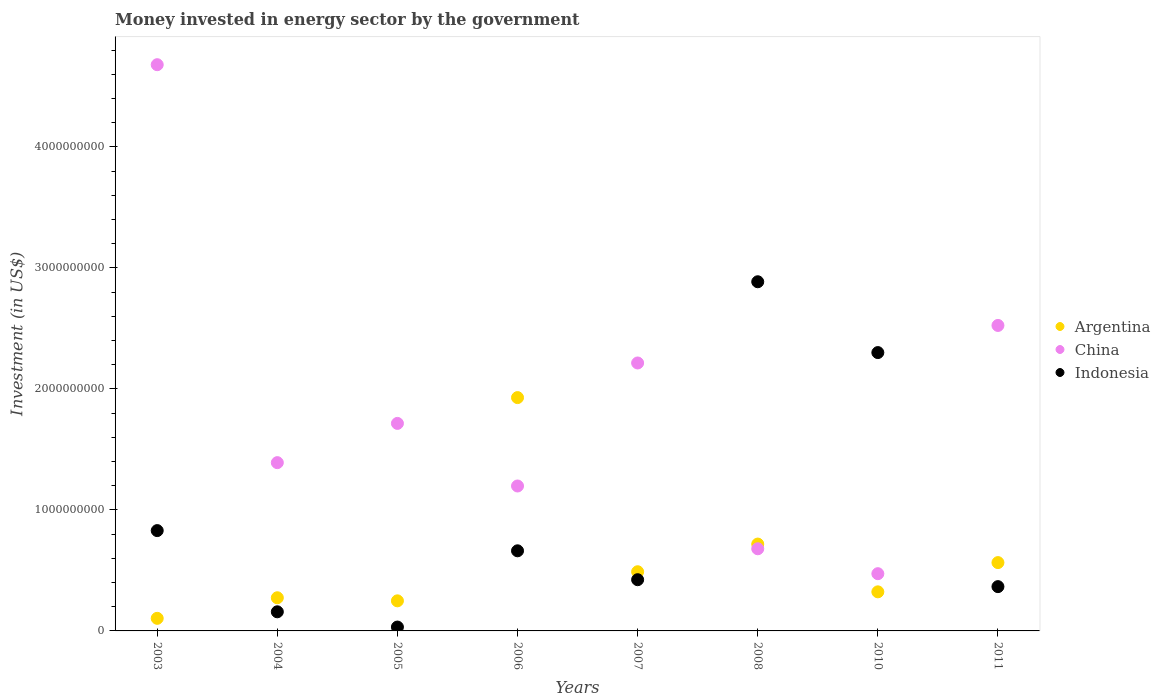How many different coloured dotlines are there?
Offer a very short reply. 3. What is the money spent in energy sector in Indonesia in 2005?
Make the answer very short. 3.20e+07. Across all years, what is the maximum money spent in energy sector in Argentina?
Keep it short and to the point. 1.93e+09. Across all years, what is the minimum money spent in energy sector in Indonesia?
Ensure brevity in your answer.  3.20e+07. In which year was the money spent in energy sector in Indonesia minimum?
Make the answer very short. 2005. What is the total money spent in energy sector in China in the graph?
Your answer should be compact. 1.49e+1. What is the difference between the money spent in energy sector in China in 2007 and that in 2011?
Make the answer very short. -3.10e+08. What is the difference between the money spent in energy sector in China in 2008 and the money spent in energy sector in Argentina in 2007?
Offer a terse response. 1.90e+08. What is the average money spent in energy sector in Indonesia per year?
Provide a succinct answer. 9.57e+08. In the year 2003, what is the difference between the money spent in energy sector in China and money spent in energy sector in Indonesia?
Your answer should be very brief. 3.85e+09. What is the ratio of the money spent in energy sector in Argentina in 2003 to that in 2008?
Offer a terse response. 0.14. Is the money spent in energy sector in China in 2003 less than that in 2004?
Offer a very short reply. No. What is the difference between the highest and the second highest money spent in energy sector in Argentina?
Your answer should be compact. 1.21e+09. What is the difference between the highest and the lowest money spent in energy sector in China?
Keep it short and to the point. 4.21e+09. In how many years, is the money spent in energy sector in Argentina greater than the average money spent in energy sector in Argentina taken over all years?
Give a very brief answer. 2. Is the sum of the money spent in energy sector in Indonesia in 2005 and 2007 greater than the maximum money spent in energy sector in China across all years?
Offer a terse response. No. Is the money spent in energy sector in Argentina strictly less than the money spent in energy sector in Indonesia over the years?
Offer a terse response. No. How many years are there in the graph?
Offer a terse response. 8. What is the difference between two consecutive major ticks on the Y-axis?
Give a very brief answer. 1.00e+09. Does the graph contain any zero values?
Give a very brief answer. No. How are the legend labels stacked?
Offer a terse response. Vertical. What is the title of the graph?
Offer a very short reply. Money invested in energy sector by the government. Does "Iran" appear as one of the legend labels in the graph?
Your answer should be very brief. No. What is the label or title of the Y-axis?
Provide a short and direct response. Investment (in US$). What is the Investment (in US$) of Argentina in 2003?
Provide a short and direct response. 1.04e+08. What is the Investment (in US$) in China in 2003?
Offer a very short reply. 4.68e+09. What is the Investment (in US$) in Indonesia in 2003?
Give a very brief answer. 8.29e+08. What is the Investment (in US$) of Argentina in 2004?
Offer a very short reply. 2.74e+08. What is the Investment (in US$) of China in 2004?
Your response must be concise. 1.39e+09. What is the Investment (in US$) in Indonesia in 2004?
Provide a short and direct response. 1.58e+08. What is the Investment (in US$) of Argentina in 2005?
Give a very brief answer. 2.49e+08. What is the Investment (in US$) in China in 2005?
Offer a very short reply. 1.71e+09. What is the Investment (in US$) of Indonesia in 2005?
Your answer should be compact. 3.20e+07. What is the Investment (in US$) in Argentina in 2006?
Your answer should be compact. 1.93e+09. What is the Investment (in US$) in China in 2006?
Give a very brief answer. 1.20e+09. What is the Investment (in US$) of Indonesia in 2006?
Make the answer very short. 6.62e+08. What is the Investment (in US$) in Argentina in 2007?
Keep it short and to the point. 4.89e+08. What is the Investment (in US$) in China in 2007?
Provide a succinct answer. 2.21e+09. What is the Investment (in US$) of Indonesia in 2007?
Offer a terse response. 4.23e+08. What is the Investment (in US$) of Argentina in 2008?
Provide a succinct answer. 7.18e+08. What is the Investment (in US$) of China in 2008?
Provide a succinct answer. 6.79e+08. What is the Investment (in US$) of Indonesia in 2008?
Ensure brevity in your answer.  2.89e+09. What is the Investment (in US$) in Argentina in 2010?
Provide a short and direct response. 3.23e+08. What is the Investment (in US$) in China in 2010?
Offer a very short reply. 4.73e+08. What is the Investment (in US$) in Indonesia in 2010?
Ensure brevity in your answer.  2.30e+09. What is the Investment (in US$) in Argentina in 2011?
Offer a terse response. 5.65e+08. What is the Investment (in US$) of China in 2011?
Your answer should be very brief. 2.52e+09. What is the Investment (in US$) in Indonesia in 2011?
Provide a short and direct response. 3.66e+08. Across all years, what is the maximum Investment (in US$) in Argentina?
Give a very brief answer. 1.93e+09. Across all years, what is the maximum Investment (in US$) of China?
Your response must be concise. 4.68e+09. Across all years, what is the maximum Investment (in US$) of Indonesia?
Your answer should be compact. 2.89e+09. Across all years, what is the minimum Investment (in US$) of Argentina?
Offer a terse response. 1.04e+08. Across all years, what is the minimum Investment (in US$) of China?
Provide a short and direct response. 4.73e+08. Across all years, what is the minimum Investment (in US$) of Indonesia?
Your answer should be compact. 3.20e+07. What is the total Investment (in US$) in Argentina in the graph?
Your answer should be compact. 4.65e+09. What is the total Investment (in US$) of China in the graph?
Provide a short and direct response. 1.49e+1. What is the total Investment (in US$) of Indonesia in the graph?
Keep it short and to the point. 7.66e+09. What is the difference between the Investment (in US$) of Argentina in 2003 and that in 2004?
Ensure brevity in your answer.  -1.70e+08. What is the difference between the Investment (in US$) of China in 2003 and that in 2004?
Give a very brief answer. 3.29e+09. What is the difference between the Investment (in US$) of Indonesia in 2003 and that in 2004?
Keep it short and to the point. 6.71e+08. What is the difference between the Investment (in US$) in Argentina in 2003 and that in 2005?
Provide a short and direct response. -1.45e+08. What is the difference between the Investment (in US$) in China in 2003 and that in 2005?
Provide a succinct answer. 2.96e+09. What is the difference between the Investment (in US$) of Indonesia in 2003 and that in 2005?
Ensure brevity in your answer.  7.97e+08. What is the difference between the Investment (in US$) in Argentina in 2003 and that in 2006?
Provide a short and direct response. -1.82e+09. What is the difference between the Investment (in US$) in China in 2003 and that in 2006?
Your answer should be very brief. 3.48e+09. What is the difference between the Investment (in US$) in Indonesia in 2003 and that in 2006?
Keep it short and to the point. 1.67e+08. What is the difference between the Investment (in US$) in Argentina in 2003 and that in 2007?
Make the answer very short. -3.85e+08. What is the difference between the Investment (in US$) of China in 2003 and that in 2007?
Provide a short and direct response. 2.46e+09. What is the difference between the Investment (in US$) in Indonesia in 2003 and that in 2007?
Offer a very short reply. 4.06e+08. What is the difference between the Investment (in US$) in Argentina in 2003 and that in 2008?
Provide a succinct answer. -6.14e+08. What is the difference between the Investment (in US$) in China in 2003 and that in 2008?
Offer a very short reply. 4.00e+09. What is the difference between the Investment (in US$) in Indonesia in 2003 and that in 2008?
Ensure brevity in your answer.  -2.06e+09. What is the difference between the Investment (in US$) of Argentina in 2003 and that in 2010?
Make the answer very short. -2.19e+08. What is the difference between the Investment (in US$) in China in 2003 and that in 2010?
Ensure brevity in your answer.  4.21e+09. What is the difference between the Investment (in US$) in Indonesia in 2003 and that in 2010?
Your answer should be compact. -1.47e+09. What is the difference between the Investment (in US$) in Argentina in 2003 and that in 2011?
Offer a terse response. -4.61e+08. What is the difference between the Investment (in US$) in China in 2003 and that in 2011?
Your answer should be very brief. 2.15e+09. What is the difference between the Investment (in US$) in Indonesia in 2003 and that in 2011?
Provide a succinct answer. 4.63e+08. What is the difference between the Investment (in US$) of Argentina in 2004 and that in 2005?
Make the answer very short. 2.54e+07. What is the difference between the Investment (in US$) in China in 2004 and that in 2005?
Your response must be concise. -3.24e+08. What is the difference between the Investment (in US$) of Indonesia in 2004 and that in 2005?
Ensure brevity in your answer.  1.26e+08. What is the difference between the Investment (in US$) of Argentina in 2004 and that in 2006?
Offer a terse response. -1.65e+09. What is the difference between the Investment (in US$) of China in 2004 and that in 2006?
Offer a terse response. 1.93e+08. What is the difference between the Investment (in US$) in Indonesia in 2004 and that in 2006?
Keep it short and to the point. -5.04e+08. What is the difference between the Investment (in US$) of Argentina in 2004 and that in 2007?
Offer a terse response. -2.15e+08. What is the difference between the Investment (in US$) in China in 2004 and that in 2007?
Offer a very short reply. -8.24e+08. What is the difference between the Investment (in US$) in Indonesia in 2004 and that in 2007?
Ensure brevity in your answer.  -2.65e+08. What is the difference between the Investment (in US$) in Argentina in 2004 and that in 2008?
Provide a short and direct response. -4.44e+08. What is the difference between the Investment (in US$) of China in 2004 and that in 2008?
Offer a very short reply. 7.12e+08. What is the difference between the Investment (in US$) of Indonesia in 2004 and that in 2008?
Your answer should be compact. -2.73e+09. What is the difference between the Investment (in US$) of Argentina in 2004 and that in 2010?
Provide a short and direct response. -4.89e+07. What is the difference between the Investment (in US$) of China in 2004 and that in 2010?
Your answer should be very brief. 9.18e+08. What is the difference between the Investment (in US$) in Indonesia in 2004 and that in 2010?
Ensure brevity in your answer.  -2.14e+09. What is the difference between the Investment (in US$) in Argentina in 2004 and that in 2011?
Ensure brevity in your answer.  -2.91e+08. What is the difference between the Investment (in US$) in China in 2004 and that in 2011?
Offer a terse response. -1.13e+09. What is the difference between the Investment (in US$) of Indonesia in 2004 and that in 2011?
Keep it short and to the point. -2.08e+08. What is the difference between the Investment (in US$) in Argentina in 2005 and that in 2006?
Offer a terse response. -1.68e+09. What is the difference between the Investment (in US$) in China in 2005 and that in 2006?
Your answer should be very brief. 5.17e+08. What is the difference between the Investment (in US$) of Indonesia in 2005 and that in 2006?
Your answer should be very brief. -6.30e+08. What is the difference between the Investment (in US$) in Argentina in 2005 and that in 2007?
Make the answer very short. -2.40e+08. What is the difference between the Investment (in US$) of China in 2005 and that in 2007?
Your answer should be very brief. -4.99e+08. What is the difference between the Investment (in US$) of Indonesia in 2005 and that in 2007?
Your answer should be compact. -3.91e+08. What is the difference between the Investment (in US$) of Argentina in 2005 and that in 2008?
Make the answer very short. -4.69e+08. What is the difference between the Investment (in US$) of China in 2005 and that in 2008?
Make the answer very short. 1.04e+09. What is the difference between the Investment (in US$) of Indonesia in 2005 and that in 2008?
Ensure brevity in your answer.  -2.85e+09. What is the difference between the Investment (in US$) of Argentina in 2005 and that in 2010?
Give a very brief answer. -7.43e+07. What is the difference between the Investment (in US$) of China in 2005 and that in 2010?
Make the answer very short. 1.24e+09. What is the difference between the Investment (in US$) of Indonesia in 2005 and that in 2010?
Give a very brief answer. -2.27e+09. What is the difference between the Investment (in US$) in Argentina in 2005 and that in 2011?
Provide a short and direct response. -3.16e+08. What is the difference between the Investment (in US$) of China in 2005 and that in 2011?
Give a very brief answer. -8.09e+08. What is the difference between the Investment (in US$) in Indonesia in 2005 and that in 2011?
Give a very brief answer. -3.34e+08. What is the difference between the Investment (in US$) in Argentina in 2006 and that in 2007?
Make the answer very short. 1.44e+09. What is the difference between the Investment (in US$) of China in 2006 and that in 2007?
Provide a succinct answer. -1.02e+09. What is the difference between the Investment (in US$) in Indonesia in 2006 and that in 2007?
Keep it short and to the point. 2.39e+08. What is the difference between the Investment (in US$) in Argentina in 2006 and that in 2008?
Provide a short and direct response. 1.21e+09. What is the difference between the Investment (in US$) of China in 2006 and that in 2008?
Keep it short and to the point. 5.19e+08. What is the difference between the Investment (in US$) of Indonesia in 2006 and that in 2008?
Offer a very short reply. -2.22e+09. What is the difference between the Investment (in US$) in Argentina in 2006 and that in 2010?
Ensure brevity in your answer.  1.61e+09. What is the difference between the Investment (in US$) of China in 2006 and that in 2010?
Keep it short and to the point. 7.25e+08. What is the difference between the Investment (in US$) of Indonesia in 2006 and that in 2010?
Offer a terse response. -1.64e+09. What is the difference between the Investment (in US$) of Argentina in 2006 and that in 2011?
Ensure brevity in your answer.  1.36e+09. What is the difference between the Investment (in US$) in China in 2006 and that in 2011?
Offer a terse response. -1.33e+09. What is the difference between the Investment (in US$) of Indonesia in 2006 and that in 2011?
Make the answer very short. 2.96e+08. What is the difference between the Investment (in US$) in Argentina in 2007 and that in 2008?
Your answer should be very brief. -2.29e+08. What is the difference between the Investment (in US$) in China in 2007 and that in 2008?
Offer a very short reply. 1.54e+09. What is the difference between the Investment (in US$) in Indonesia in 2007 and that in 2008?
Keep it short and to the point. -2.46e+09. What is the difference between the Investment (in US$) in Argentina in 2007 and that in 2010?
Offer a very short reply. 1.66e+08. What is the difference between the Investment (in US$) of China in 2007 and that in 2010?
Ensure brevity in your answer.  1.74e+09. What is the difference between the Investment (in US$) of Indonesia in 2007 and that in 2010?
Give a very brief answer. -1.88e+09. What is the difference between the Investment (in US$) of Argentina in 2007 and that in 2011?
Offer a very short reply. -7.56e+07. What is the difference between the Investment (in US$) of China in 2007 and that in 2011?
Your response must be concise. -3.10e+08. What is the difference between the Investment (in US$) of Indonesia in 2007 and that in 2011?
Your response must be concise. 5.72e+07. What is the difference between the Investment (in US$) of Argentina in 2008 and that in 2010?
Your answer should be very brief. 3.95e+08. What is the difference between the Investment (in US$) in China in 2008 and that in 2010?
Your answer should be compact. 2.06e+08. What is the difference between the Investment (in US$) of Indonesia in 2008 and that in 2010?
Offer a terse response. 5.85e+08. What is the difference between the Investment (in US$) of Argentina in 2008 and that in 2011?
Give a very brief answer. 1.53e+08. What is the difference between the Investment (in US$) of China in 2008 and that in 2011?
Offer a terse response. -1.85e+09. What is the difference between the Investment (in US$) of Indonesia in 2008 and that in 2011?
Your response must be concise. 2.52e+09. What is the difference between the Investment (in US$) in Argentina in 2010 and that in 2011?
Offer a terse response. -2.42e+08. What is the difference between the Investment (in US$) of China in 2010 and that in 2011?
Offer a very short reply. -2.05e+09. What is the difference between the Investment (in US$) of Indonesia in 2010 and that in 2011?
Make the answer very short. 1.93e+09. What is the difference between the Investment (in US$) of Argentina in 2003 and the Investment (in US$) of China in 2004?
Provide a succinct answer. -1.29e+09. What is the difference between the Investment (in US$) of Argentina in 2003 and the Investment (in US$) of Indonesia in 2004?
Offer a very short reply. -5.40e+07. What is the difference between the Investment (in US$) in China in 2003 and the Investment (in US$) in Indonesia in 2004?
Make the answer very short. 4.52e+09. What is the difference between the Investment (in US$) in Argentina in 2003 and the Investment (in US$) in China in 2005?
Give a very brief answer. -1.61e+09. What is the difference between the Investment (in US$) in Argentina in 2003 and the Investment (in US$) in Indonesia in 2005?
Give a very brief answer. 7.20e+07. What is the difference between the Investment (in US$) of China in 2003 and the Investment (in US$) of Indonesia in 2005?
Ensure brevity in your answer.  4.65e+09. What is the difference between the Investment (in US$) of Argentina in 2003 and the Investment (in US$) of China in 2006?
Offer a terse response. -1.09e+09. What is the difference between the Investment (in US$) of Argentina in 2003 and the Investment (in US$) of Indonesia in 2006?
Provide a short and direct response. -5.58e+08. What is the difference between the Investment (in US$) in China in 2003 and the Investment (in US$) in Indonesia in 2006?
Offer a very short reply. 4.02e+09. What is the difference between the Investment (in US$) in Argentina in 2003 and the Investment (in US$) in China in 2007?
Give a very brief answer. -2.11e+09. What is the difference between the Investment (in US$) in Argentina in 2003 and the Investment (in US$) in Indonesia in 2007?
Provide a short and direct response. -3.19e+08. What is the difference between the Investment (in US$) of China in 2003 and the Investment (in US$) of Indonesia in 2007?
Ensure brevity in your answer.  4.26e+09. What is the difference between the Investment (in US$) in Argentina in 2003 and the Investment (in US$) in China in 2008?
Make the answer very short. -5.75e+08. What is the difference between the Investment (in US$) in Argentina in 2003 and the Investment (in US$) in Indonesia in 2008?
Offer a terse response. -2.78e+09. What is the difference between the Investment (in US$) in China in 2003 and the Investment (in US$) in Indonesia in 2008?
Offer a terse response. 1.79e+09. What is the difference between the Investment (in US$) in Argentina in 2003 and the Investment (in US$) in China in 2010?
Offer a terse response. -3.69e+08. What is the difference between the Investment (in US$) of Argentina in 2003 and the Investment (in US$) of Indonesia in 2010?
Ensure brevity in your answer.  -2.20e+09. What is the difference between the Investment (in US$) of China in 2003 and the Investment (in US$) of Indonesia in 2010?
Keep it short and to the point. 2.38e+09. What is the difference between the Investment (in US$) in Argentina in 2003 and the Investment (in US$) in China in 2011?
Keep it short and to the point. -2.42e+09. What is the difference between the Investment (in US$) in Argentina in 2003 and the Investment (in US$) in Indonesia in 2011?
Your answer should be compact. -2.62e+08. What is the difference between the Investment (in US$) of China in 2003 and the Investment (in US$) of Indonesia in 2011?
Make the answer very short. 4.31e+09. What is the difference between the Investment (in US$) in Argentina in 2004 and the Investment (in US$) in China in 2005?
Give a very brief answer. -1.44e+09. What is the difference between the Investment (in US$) of Argentina in 2004 and the Investment (in US$) of Indonesia in 2005?
Provide a succinct answer. 2.42e+08. What is the difference between the Investment (in US$) in China in 2004 and the Investment (in US$) in Indonesia in 2005?
Ensure brevity in your answer.  1.36e+09. What is the difference between the Investment (in US$) in Argentina in 2004 and the Investment (in US$) in China in 2006?
Make the answer very short. -9.24e+08. What is the difference between the Investment (in US$) of Argentina in 2004 and the Investment (in US$) of Indonesia in 2006?
Make the answer very short. -3.88e+08. What is the difference between the Investment (in US$) in China in 2004 and the Investment (in US$) in Indonesia in 2006?
Give a very brief answer. 7.28e+08. What is the difference between the Investment (in US$) of Argentina in 2004 and the Investment (in US$) of China in 2007?
Offer a very short reply. -1.94e+09. What is the difference between the Investment (in US$) of Argentina in 2004 and the Investment (in US$) of Indonesia in 2007?
Your answer should be compact. -1.49e+08. What is the difference between the Investment (in US$) of China in 2004 and the Investment (in US$) of Indonesia in 2007?
Offer a terse response. 9.67e+08. What is the difference between the Investment (in US$) of Argentina in 2004 and the Investment (in US$) of China in 2008?
Keep it short and to the point. -4.05e+08. What is the difference between the Investment (in US$) in Argentina in 2004 and the Investment (in US$) in Indonesia in 2008?
Ensure brevity in your answer.  -2.61e+09. What is the difference between the Investment (in US$) in China in 2004 and the Investment (in US$) in Indonesia in 2008?
Give a very brief answer. -1.49e+09. What is the difference between the Investment (in US$) of Argentina in 2004 and the Investment (in US$) of China in 2010?
Keep it short and to the point. -1.99e+08. What is the difference between the Investment (in US$) of Argentina in 2004 and the Investment (in US$) of Indonesia in 2010?
Provide a short and direct response. -2.03e+09. What is the difference between the Investment (in US$) of China in 2004 and the Investment (in US$) of Indonesia in 2010?
Keep it short and to the point. -9.10e+08. What is the difference between the Investment (in US$) in Argentina in 2004 and the Investment (in US$) in China in 2011?
Give a very brief answer. -2.25e+09. What is the difference between the Investment (in US$) of Argentina in 2004 and the Investment (in US$) of Indonesia in 2011?
Your answer should be very brief. -9.20e+07. What is the difference between the Investment (in US$) in China in 2004 and the Investment (in US$) in Indonesia in 2011?
Your answer should be compact. 1.02e+09. What is the difference between the Investment (in US$) in Argentina in 2005 and the Investment (in US$) in China in 2006?
Your answer should be very brief. -9.49e+08. What is the difference between the Investment (in US$) of Argentina in 2005 and the Investment (in US$) of Indonesia in 2006?
Your answer should be very brief. -4.13e+08. What is the difference between the Investment (in US$) in China in 2005 and the Investment (in US$) in Indonesia in 2006?
Keep it short and to the point. 1.05e+09. What is the difference between the Investment (in US$) of Argentina in 2005 and the Investment (in US$) of China in 2007?
Your answer should be very brief. -1.97e+09. What is the difference between the Investment (in US$) of Argentina in 2005 and the Investment (in US$) of Indonesia in 2007?
Give a very brief answer. -1.75e+08. What is the difference between the Investment (in US$) of China in 2005 and the Investment (in US$) of Indonesia in 2007?
Make the answer very short. 1.29e+09. What is the difference between the Investment (in US$) of Argentina in 2005 and the Investment (in US$) of China in 2008?
Offer a terse response. -4.30e+08. What is the difference between the Investment (in US$) in Argentina in 2005 and the Investment (in US$) in Indonesia in 2008?
Offer a very short reply. -2.64e+09. What is the difference between the Investment (in US$) in China in 2005 and the Investment (in US$) in Indonesia in 2008?
Offer a terse response. -1.17e+09. What is the difference between the Investment (in US$) of Argentina in 2005 and the Investment (in US$) of China in 2010?
Your answer should be very brief. -2.24e+08. What is the difference between the Investment (in US$) in Argentina in 2005 and the Investment (in US$) in Indonesia in 2010?
Your answer should be compact. -2.05e+09. What is the difference between the Investment (in US$) in China in 2005 and the Investment (in US$) in Indonesia in 2010?
Offer a terse response. -5.85e+08. What is the difference between the Investment (in US$) in Argentina in 2005 and the Investment (in US$) in China in 2011?
Your answer should be very brief. -2.28e+09. What is the difference between the Investment (in US$) of Argentina in 2005 and the Investment (in US$) of Indonesia in 2011?
Keep it short and to the point. -1.17e+08. What is the difference between the Investment (in US$) of China in 2005 and the Investment (in US$) of Indonesia in 2011?
Ensure brevity in your answer.  1.35e+09. What is the difference between the Investment (in US$) in Argentina in 2006 and the Investment (in US$) in China in 2007?
Give a very brief answer. -2.86e+08. What is the difference between the Investment (in US$) of Argentina in 2006 and the Investment (in US$) of Indonesia in 2007?
Provide a succinct answer. 1.50e+09. What is the difference between the Investment (in US$) of China in 2006 and the Investment (in US$) of Indonesia in 2007?
Offer a very short reply. 7.74e+08. What is the difference between the Investment (in US$) in Argentina in 2006 and the Investment (in US$) in China in 2008?
Your answer should be very brief. 1.25e+09. What is the difference between the Investment (in US$) in Argentina in 2006 and the Investment (in US$) in Indonesia in 2008?
Make the answer very short. -9.57e+08. What is the difference between the Investment (in US$) in China in 2006 and the Investment (in US$) in Indonesia in 2008?
Provide a succinct answer. -1.69e+09. What is the difference between the Investment (in US$) of Argentina in 2006 and the Investment (in US$) of China in 2010?
Ensure brevity in your answer.  1.46e+09. What is the difference between the Investment (in US$) of Argentina in 2006 and the Investment (in US$) of Indonesia in 2010?
Provide a short and direct response. -3.72e+08. What is the difference between the Investment (in US$) of China in 2006 and the Investment (in US$) of Indonesia in 2010?
Your answer should be very brief. -1.10e+09. What is the difference between the Investment (in US$) in Argentina in 2006 and the Investment (in US$) in China in 2011?
Provide a short and direct response. -5.96e+08. What is the difference between the Investment (in US$) of Argentina in 2006 and the Investment (in US$) of Indonesia in 2011?
Provide a short and direct response. 1.56e+09. What is the difference between the Investment (in US$) in China in 2006 and the Investment (in US$) in Indonesia in 2011?
Provide a succinct answer. 8.32e+08. What is the difference between the Investment (in US$) in Argentina in 2007 and the Investment (in US$) in China in 2008?
Your response must be concise. -1.90e+08. What is the difference between the Investment (in US$) of Argentina in 2007 and the Investment (in US$) of Indonesia in 2008?
Keep it short and to the point. -2.40e+09. What is the difference between the Investment (in US$) in China in 2007 and the Investment (in US$) in Indonesia in 2008?
Provide a succinct answer. -6.71e+08. What is the difference between the Investment (in US$) of Argentina in 2007 and the Investment (in US$) of China in 2010?
Your answer should be compact. 1.60e+07. What is the difference between the Investment (in US$) in Argentina in 2007 and the Investment (in US$) in Indonesia in 2010?
Provide a succinct answer. -1.81e+09. What is the difference between the Investment (in US$) of China in 2007 and the Investment (in US$) of Indonesia in 2010?
Offer a terse response. -8.60e+07. What is the difference between the Investment (in US$) of Argentina in 2007 and the Investment (in US$) of China in 2011?
Provide a succinct answer. -2.04e+09. What is the difference between the Investment (in US$) of Argentina in 2007 and the Investment (in US$) of Indonesia in 2011?
Give a very brief answer. 1.23e+08. What is the difference between the Investment (in US$) in China in 2007 and the Investment (in US$) in Indonesia in 2011?
Provide a short and direct response. 1.85e+09. What is the difference between the Investment (in US$) of Argentina in 2008 and the Investment (in US$) of China in 2010?
Keep it short and to the point. 2.45e+08. What is the difference between the Investment (in US$) in Argentina in 2008 and the Investment (in US$) in Indonesia in 2010?
Provide a short and direct response. -1.58e+09. What is the difference between the Investment (in US$) of China in 2008 and the Investment (in US$) of Indonesia in 2010?
Make the answer very short. -1.62e+09. What is the difference between the Investment (in US$) in Argentina in 2008 and the Investment (in US$) in China in 2011?
Your answer should be very brief. -1.81e+09. What is the difference between the Investment (in US$) of Argentina in 2008 and the Investment (in US$) of Indonesia in 2011?
Make the answer very short. 3.52e+08. What is the difference between the Investment (in US$) in China in 2008 and the Investment (in US$) in Indonesia in 2011?
Provide a short and direct response. 3.13e+08. What is the difference between the Investment (in US$) in Argentina in 2010 and the Investment (in US$) in China in 2011?
Your response must be concise. -2.20e+09. What is the difference between the Investment (in US$) of Argentina in 2010 and the Investment (in US$) of Indonesia in 2011?
Make the answer very short. -4.31e+07. What is the difference between the Investment (in US$) in China in 2010 and the Investment (in US$) in Indonesia in 2011?
Your answer should be compact. 1.07e+08. What is the average Investment (in US$) of Argentina per year?
Your answer should be very brief. 5.81e+08. What is the average Investment (in US$) of China per year?
Your answer should be very brief. 1.86e+09. What is the average Investment (in US$) of Indonesia per year?
Your answer should be very brief. 9.57e+08. In the year 2003, what is the difference between the Investment (in US$) in Argentina and Investment (in US$) in China?
Provide a succinct answer. -4.57e+09. In the year 2003, what is the difference between the Investment (in US$) of Argentina and Investment (in US$) of Indonesia?
Your answer should be very brief. -7.25e+08. In the year 2003, what is the difference between the Investment (in US$) of China and Investment (in US$) of Indonesia?
Offer a terse response. 3.85e+09. In the year 2004, what is the difference between the Investment (in US$) of Argentina and Investment (in US$) of China?
Offer a terse response. -1.12e+09. In the year 2004, what is the difference between the Investment (in US$) of Argentina and Investment (in US$) of Indonesia?
Provide a short and direct response. 1.16e+08. In the year 2004, what is the difference between the Investment (in US$) in China and Investment (in US$) in Indonesia?
Your response must be concise. 1.23e+09. In the year 2005, what is the difference between the Investment (in US$) in Argentina and Investment (in US$) in China?
Provide a succinct answer. -1.47e+09. In the year 2005, what is the difference between the Investment (in US$) of Argentina and Investment (in US$) of Indonesia?
Ensure brevity in your answer.  2.17e+08. In the year 2005, what is the difference between the Investment (in US$) in China and Investment (in US$) in Indonesia?
Keep it short and to the point. 1.68e+09. In the year 2006, what is the difference between the Investment (in US$) of Argentina and Investment (in US$) of China?
Provide a short and direct response. 7.30e+08. In the year 2006, what is the difference between the Investment (in US$) in Argentina and Investment (in US$) in Indonesia?
Your answer should be very brief. 1.27e+09. In the year 2006, what is the difference between the Investment (in US$) in China and Investment (in US$) in Indonesia?
Offer a terse response. 5.36e+08. In the year 2007, what is the difference between the Investment (in US$) in Argentina and Investment (in US$) in China?
Provide a succinct answer. -1.73e+09. In the year 2007, what is the difference between the Investment (in US$) in Argentina and Investment (in US$) in Indonesia?
Give a very brief answer. 6.58e+07. In the year 2007, what is the difference between the Investment (in US$) of China and Investment (in US$) of Indonesia?
Your answer should be very brief. 1.79e+09. In the year 2008, what is the difference between the Investment (in US$) of Argentina and Investment (in US$) of China?
Your answer should be compact. 3.90e+07. In the year 2008, what is the difference between the Investment (in US$) in Argentina and Investment (in US$) in Indonesia?
Provide a short and direct response. -2.17e+09. In the year 2008, what is the difference between the Investment (in US$) in China and Investment (in US$) in Indonesia?
Provide a succinct answer. -2.21e+09. In the year 2010, what is the difference between the Investment (in US$) in Argentina and Investment (in US$) in China?
Your response must be concise. -1.50e+08. In the year 2010, what is the difference between the Investment (in US$) in Argentina and Investment (in US$) in Indonesia?
Make the answer very short. -1.98e+09. In the year 2010, what is the difference between the Investment (in US$) in China and Investment (in US$) in Indonesia?
Provide a succinct answer. -1.83e+09. In the year 2011, what is the difference between the Investment (in US$) of Argentina and Investment (in US$) of China?
Ensure brevity in your answer.  -1.96e+09. In the year 2011, what is the difference between the Investment (in US$) of Argentina and Investment (in US$) of Indonesia?
Offer a terse response. 1.99e+08. In the year 2011, what is the difference between the Investment (in US$) of China and Investment (in US$) of Indonesia?
Give a very brief answer. 2.16e+09. What is the ratio of the Investment (in US$) of Argentina in 2003 to that in 2004?
Provide a succinct answer. 0.38. What is the ratio of the Investment (in US$) in China in 2003 to that in 2004?
Your response must be concise. 3.36. What is the ratio of the Investment (in US$) in Indonesia in 2003 to that in 2004?
Ensure brevity in your answer.  5.25. What is the ratio of the Investment (in US$) of Argentina in 2003 to that in 2005?
Provide a succinct answer. 0.42. What is the ratio of the Investment (in US$) of China in 2003 to that in 2005?
Your answer should be compact. 2.73. What is the ratio of the Investment (in US$) in Indonesia in 2003 to that in 2005?
Make the answer very short. 25.91. What is the ratio of the Investment (in US$) in Argentina in 2003 to that in 2006?
Ensure brevity in your answer.  0.05. What is the ratio of the Investment (in US$) of China in 2003 to that in 2006?
Offer a terse response. 3.91. What is the ratio of the Investment (in US$) of Indonesia in 2003 to that in 2006?
Your response must be concise. 1.25. What is the ratio of the Investment (in US$) of Argentina in 2003 to that in 2007?
Your answer should be compact. 0.21. What is the ratio of the Investment (in US$) in China in 2003 to that in 2007?
Give a very brief answer. 2.11. What is the ratio of the Investment (in US$) of Indonesia in 2003 to that in 2007?
Provide a short and direct response. 1.96. What is the ratio of the Investment (in US$) in Argentina in 2003 to that in 2008?
Provide a short and direct response. 0.14. What is the ratio of the Investment (in US$) of China in 2003 to that in 2008?
Offer a very short reply. 6.89. What is the ratio of the Investment (in US$) of Indonesia in 2003 to that in 2008?
Your answer should be very brief. 0.29. What is the ratio of the Investment (in US$) in Argentina in 2003 to that in 2010?
Provide a short and direct response. 0.32. What is the ratio of the Investment (in US$) in China in 2003 to that in 2010?
Keep it short and to the point. 9.89. What is the ratio of the Investment (in US$) of Indonesia in 2003 to that in 2010?
Offer a very short reply. 0.36. What is the ratio of the Investment (in US$) in Argentina in 2003 to that in 2011?
Provide a short and direct response. 0.18. What is the ratio of the Investment (in US$) of China in 2003 to that in 2011?
Ensure brevity in your answer.  1.85. What is the ratio of the Investment (in US$) in Indonesia in 2003 to that in 2011?
Provide a short and direct response. 2.27. What is the ratio of the Investment (in US$) in Argentina in 2004 to that in 2005?
Your answer should be very brief. 1.1. What is the ratio of the Investment (in US$) in China in 2004 to that in 2005?
Give a very brief answer. 0.81. What is the ratio of the Investment (in US$) in Indonesia in 2004 to that in 2005?
Give a very brief answer. 4.94. What is the ratio of the Investment (in US$) in Argentina in 2004 to that in 2006?
Provide a succinct answer. 0.14. What is the ratio of the Investment (in US$) of China in 2004 to that in 2006?
Your answer should be very brief. 1.16. What is the ratio of the Investment (in US$) in Indonesia in 2004 to that in 2006?
Your response must be concise. 0.24. What is the ratio of the Investment (in US$) of Argentina in 2004 to that in 2007?
Your answer should be compact. 0.56. What is the ratio of the Investment (in US$) in China in 2004 to that in 2007?
Your answer should be compact. 0.63. What is the ratio of the Investment (in US$) of Indonesia in 2004 to that in 2007?
Ensure brevity in your answer.  0.37. What is the ratio of the Investment (in US$) in Argentina in 2004 to that in 2008?
Offer a very short reply. 0.38. What is the ratio of the Investment (in US$) in China in 2004 to that in 2008?
Provide a succinct answer. 2.05. What is the ratio of the Investment (in US$) of Indonesia in 2004 to that in 2008?
Give a very brief answer. 0.05. What is the ratio of the Investment (in US$) in Argentina in 2004 to that in 2010?
Ensure brevity in your answer.  0.85. What is the ratio of the Investment (in US$) in China in 2004 to that in 2010?
Keep it short and to the point. 2.94. What is the ratio of the Investment (in US$) of Indonesia in 2004 to that in 2010?
Your answer should be very brief. 0.07. What is the ratio of the Investment (in US$) in Argentina in 2004 to that in 2011?
Make the answer very short. 0.49. What is the ratio of the Investment (in US$) of China in 2004 to that in 2011?
Ensure brevity in your answer.  0.55. What is the ratio of the Investment (in US$) in Indonesia in 2004 to that in 2011?
Provide a short and direct response. 0.43. What is the ratio of the Investment (in US$) in Argentina in 2005 to that in 2006?
Give a very brief answer. 0.13. What is the ratio of the Investment (in US$) of China in 2005 to that in 2006?
Your answer should be compact. 1.43. What is the ratio of the Investment (in US$) of Indonesia in 2005 to that in 2006?
Provide a short and direct response. 0.05. What is the ratio of the Investment (in US$) in Argentina in 2005 to that in 2007?
Keep it short and to the point. 0.51. What is the ratio of the Investment (in US$) in China in 2005 to that in 2007?
Offer a very short reply. 0.77. What is the ratio of the Investment (in US$) of Indonesia in 2005 to that in 2007?
Your response must be concise. 0.08. What is the ratio of the Investment (in US$) of Argentina in 2005 to that in 2008?
Make the answer very short. 0.35. What is the ratio of the Investment (in US$) of China in 2005 to that in 2008?
Give a very brief answer. 2.53. What is the ratio of the Investment (in US$) of Indonesia in 2005 to that in 2008?
Make the answer very short. 0.01. What is the ratio of the Investment (in US$) in Argentina in 2005 to that in 2010?
Offer a terse response. 0.77. What is the ratio of the Investment (in US$) of China in 2005 to that in 2010?
Your response must be concise. 3.63. What is the ratio of the Investment (in US$) in Indonesia in 2005 to that in 2010?
Your answer should be compact. 0.01. What is the ratio of the Investment (in US$) in Argentina in 2005 to that in 2011?
Ensure brevity in your answer.  0.44. What is the ratio of the Investment (in US$) in China in 2005 to that in 2011?
Your response must be concise. 0.68. What is the ratio of the Investment (in US$) in Indonesia in 2005 to that in 2011?
Ensure brevity in your answer.  0.09. What is the ratio of the Investment (in US$) of Argentina in 2006 to that in 2007?
Provide a short and direct response. 3.94. What is the ratio of the Investment (in US$) in China in 2006 to that in 2007?
Provide a succinct answer. 0.54. What is the ratio of the Investment (in US$) of Indonesia in 2006 to that in 2007?
Provide a short and direct response. 1.56. What is the ratio of the Investment (in US$) of Argentina in 2006 to that in 2008?
Your answer should be very brief. 2.69. What is the ratio of the Investment (in US$) in China in 2006 to that in 2008?
Give a very brief answer. 1.76. What is the ratio of the Investment (in US$) in Indonesia in 2006 to that in 2008?
Keep it short and to the point. 0.23. What is the ratio of the Investment (in US$) in Argentina in 2006 to that in 2010?
Your answer should be very brief. 5.97. What is the ratio of the Investment (in US$) in China in 2006 to that in 2010?
Provide a short and direct response. 2.53. What is the ratio of the Investment (in US$) of Indonesia in 2006 to that in 2010?
Offer a terse response. 0.29. What is the ratio of the Investment (in US$) of Argentina in 2006 to that in 2011?
Your response must be concise. 3.41. What is the ratio of the Investment (in US$) of China in 2006 to that in 2011?
Give a very brief answer. 0.47. What is the ratio of the Investment (in US$) in Indonesia in 2006 to that in 2011?
Provide a short and direct response. 1.81. What is the ratio of the Investment (in US$) of Argentina in 2007 to that in 2008?
Your response must be concise. 0.68. What is the ratio of the Investment (in US$) in China in 2007 to that in 2008?
Offer a terse response. 3.26. What is the ratio of the Investment (in US$) of Indonesia in 2007 to that in 2008?
Offer a terse response. 0.15. What is the ratio of the Investment (in US$) in Argentina in 2007 to that in 2010?
Offer a terse response. 1.51. What is the ratio of the Investment (in US$) of China in 2007 to that in 2010?
Make the answer very short. 4.68. What is the ratio of the Investment (in US$) of Indonesia in 2007 to that in 2010?
Provide a succinct answer. 0.18. What is the ratio of the Investment (in US$) in Argentina in 2007 to that in 2011?
Offer a terse response. 0.87. What is the ratio of the Investment (in US$) of China in 2007 to that in 2011?
Make the answer very short. 0.88. What is the ratio of the Investment (in US$) in Indonesia in 2007 to that in 2011?
Your response must be concise. 1.16. What is the ratio of the Investment (in US$) of Argentina in 2008 to that in 2010?
Make the answer very short. 2.22. What is the ratio of the Investment (in US$) of China in 2008 to that in 2010?
Ensure brevity in your answer.  1.44. What is the ratio of the Investment (in US$) of Indonesia in 2008 to that in 2010?
Offer a terse response. 1.25. What is the ratio of the Investment (in US$) in Argentina in 2008 to that in 2011?
Your answer should be compact. 1.27. What is the ratio of the Investment (in US$) of China in 2008 to that in 2011?
Your answer should be compact. 0.27. What is the ratio of the Investment (in US$) of Indonesia in 2008 to that in 2011?
Offer a terse response. 7.88. What is the ratio of the Investment (in US$) of Argentina in 2010 to that in 2011?
Provide a succinct answer. 0.57. What is the ratio of the Investment (in US$) in China in 2010 to that in 2011?
Provide a short and direct response. 0.19. What is the ratio of the Investment (in US$) of Indonesia in 2010 to that in 2011?
Your response must be concise. 6.28. What is the difference between the highest and the second highest Investment (in US$) of Argentina?
Your response must be concise. 1.21e+09. What is the difference between the highest and the second highest Investment (in US$) of China?
Make the answer very short. 2.15e+09. What is the difference between the highest and the second highest Investment (in US$) in Indonesia?
Make the answer very short. 5.85e+08. What is the difference between the highest and the lowest Investment (in US$) of Argentina?
Your response must be concise. 1.82e+09. What is the difference between the highest and the lowest Investment (in US$) of China?
Provide a short and direct response. 4.21e+09. What is the difference between the highest and the lowest Investment (in US$) in Indonesia?
Make the answer very short. 2.85e+09. 